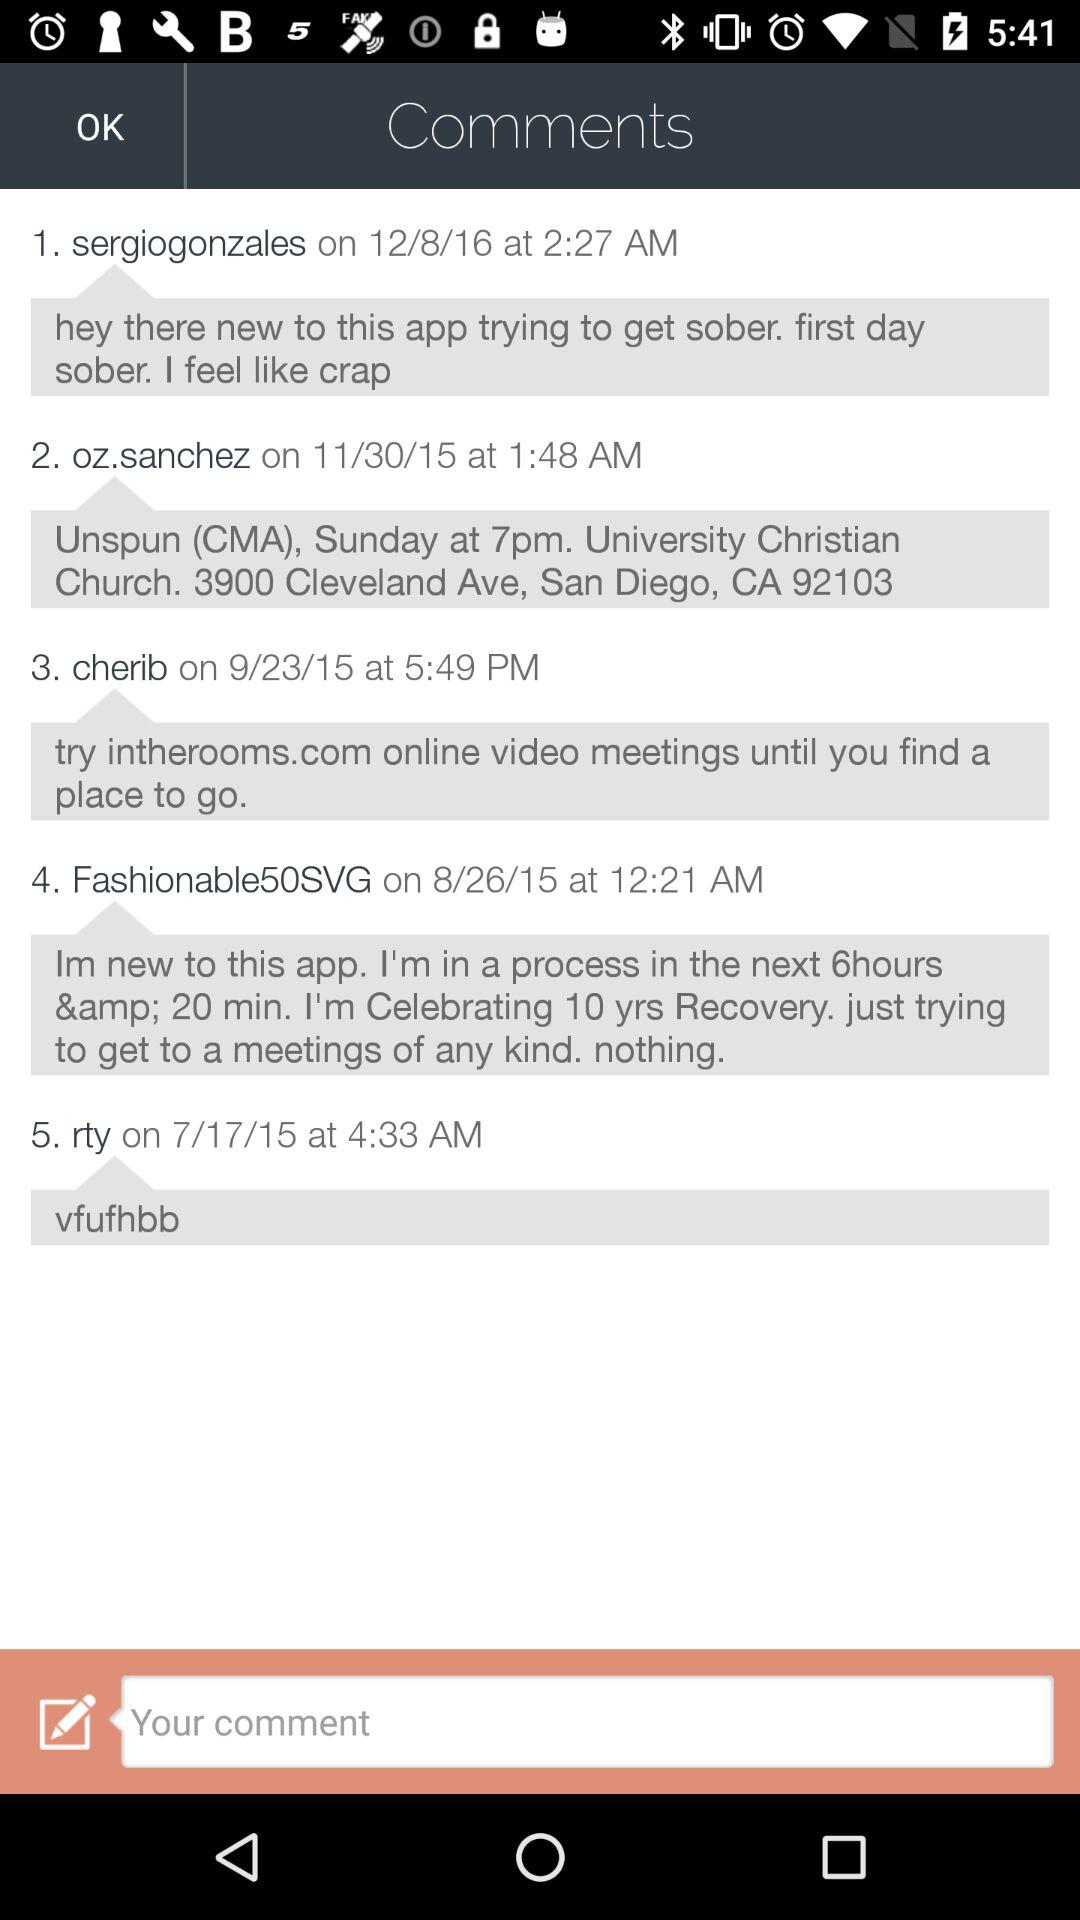How many comments are there on this screen?
Answer the question using a single word or phrase. 5 